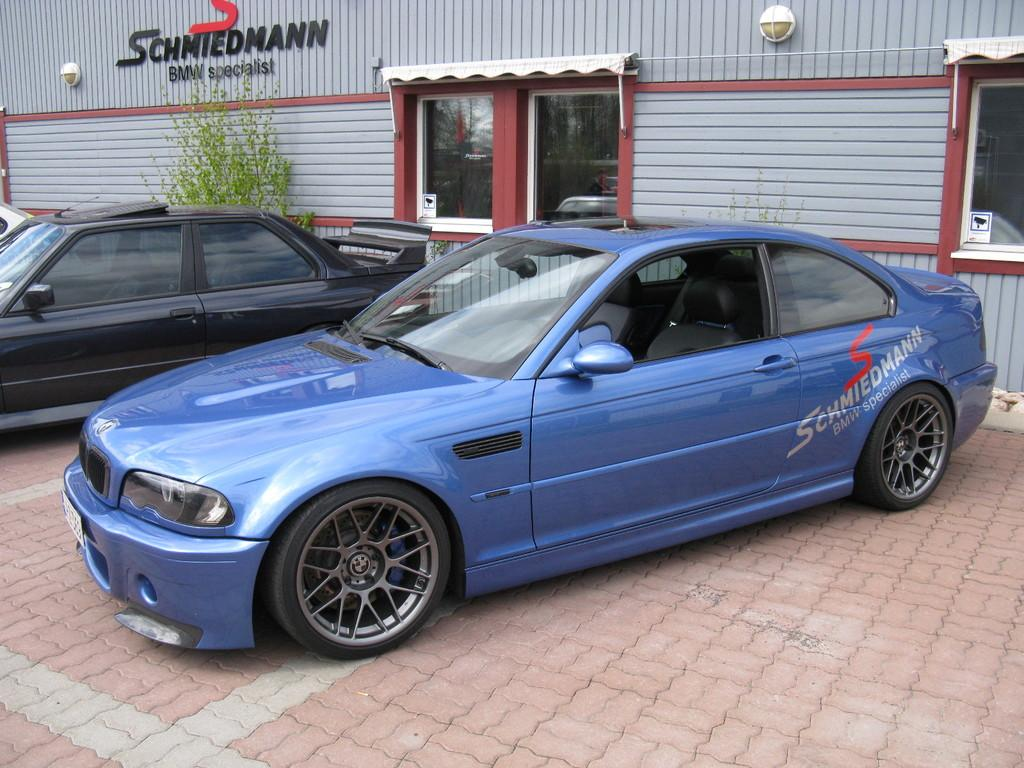What type of vehicles can be seen in the image? There are cars in the image. What other objects or elements are present in the image? There are plants and a building in the image. What type of soap is being used to clean the building in the image? There is no soap or cleaning activity depicted in the image; it only shows cars, plants, and a building. 